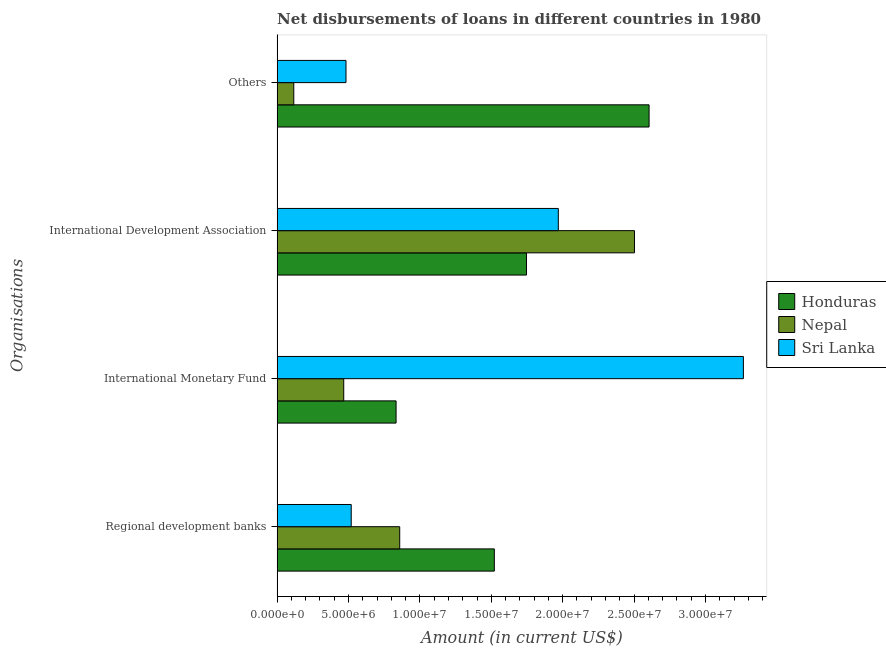What is the label of the 1st group of bars from the top?
Your response must be concise. Others. What is the amount of loan disimbursed by other organisations in Sri Lanka?
Make the answer very short. 4.82e+06. Across all countries, what is the maximum amount of loan disimbursed by international development association?
Offer a very short reply. 2.50e+07. Across all countries, what is the minimum amount of loan disimbursed by international development association?
Provide a succinct answer. 1.75e+07. In which country was the amount of loan disimbursed by international monetary fund maximum?
Give a very brief answer. Sri Lanka. In which country was the amount of loan disimbursed by international monetary fund minimum?
Your answer should be very brief. Nepal. What is the total amount of loan disimbursed by international development association in the graph?
Ensure brevity in your answer.  6.22e+07. What is the difference between the amount of loan disimbursed by international development association in Sri Lanka and that in Nepal?
Offer a very short reply. -5.33e+06. What is the difference between the amount of loan disimbursed by regional development banks in Honduras and the amount of loan disimbursed by international development association in Sri Lanka?
Your answer should be compact. -4.48e+06. What is the average amount of loan disimbursed by international development association per country?
Your answer should be very brief. 2.07e+07. What is the difference between the amount of loan disimbursed by international monetary fund and amount of loan disimbursed by regional development banks in Nepal?
Keep it short and to the point. -3.92e+06. In how many countries, is the amount of loan disimbursed by regional development banks greater than 14000000 US$?
Your answer should be very brief. 1. What is the ratio of the amount of loan disimbursed by other organisations in Honduras to that in Sri Lanka?
Your answer should be very brief. 5.4. Is the amount of loan disimbursed by regional development banks in Honduras less than that in Sri Lanka?
Keep it short and to the point. No. What is the difference between the highest and the second highest amount of loan disimbursed by international monetary fund?
Provide a succinct answer. 2.43e+07. What is the difference between the highest and the lowest amount of loan disimbursed by international monetary fund?
Offer a terse response. 2.80e+07. Is it the case that in every country, the sum of the amount of loan disimbursed by other organisations and amount of loan disimbursed by international development association is greater than the sum of amount of loan disimbursed by international monetary fund and amount of loan disimbursed by regional development banks?
Your answer should be compact. Yes. What does the 3rd bar from the top in International Development Association represents?
Your answer should be compact. Honduras. What does the 3rd bar from the bottom in International Monetary Fund represents?
Your answer should be compact. Sri Lanka. Are all the bars in the graph horizontal?
Keep it short and to the point. Yes. How many countries are there in the graph?
Make the answer very short. 3. What is the difference between two consecutive major ticks on the X-axis?
Provide a short and direct response. 5.00e+06. Are the values on the major ticks of X-axis written in scientific E-notation?
Ensure brevity in your answer.  Yes. Does the graph contain any zero values?
Provide a succinct answer. No. Does the graph contain grids?
Provide a short and direct response. No. Where does the legend appear in the graph?
Make the answer very short. Center right. What is the title of the graph?
Keep it short and to the point. Net disbursements of loans in different countries in 1980. What is the label or title of the X-axis?
Offer a very short reply. Amount (in current US$). What is the label or title of the Y-axis?
Your response must be concise. Organisations. What is the Amount (in current US$) in Honduras in Regional development banks?
Provide a succinct answer. 1.52e+07. What is the Amount (in current US$) in Nepal in Regional development banks?
Your response must be concise. 8.58e+06. What is the Amount (in current US$) in Sri Lanka in Regional development banks?
Ensure brevity in your answer.  5.19e+06. What is the Amount (in current US$) in Honduras in International Monetary Fund?
Offer a terse response. 8.33e+06. What is the Amount (in current US$) of Nepal in International Monetary Fund?
Your response must be concise. 4.66e+06. What is the Amount (in current US$) of Sri Lanka in International Monetary Fund?
Your response must be concise. 3.27e+07. What is the Amount (in current US$) of Honduras in International Development Association?
Your answer should be compact. 1.75e+07. What is the Amount (in current US$) of Nepal in International Development Association?
Provide a short and direct response. 2.50e+07. What is the Amount (in current US$) of Sri Lanka in International Development Association?
Provide a short and direct response. 1.97e+07. What is the Amount (in current US$) of Honduras in Others?
Your answer should be compact. 2.60e+07. What is the Amount (in current US$) in Nepal in Others?
Your answer should be compact. 1.17e+06. What is the Amount (in current US$) of Sri Lanka in Others?
Your answer should be very brief. 4.82e+06. Across all Organisations, what is the maximum Amount (in current US$) of Honduras?
Ensure brevity in your answer.  2.60e+07. Across all Organisations, what is the maximum Amount (in current US$) of Nepal?
Offer a very short reply. 2.50e+07. Across all Organisations, what is the maximum Amount (in current US$) in Sri Lanka?
Your answer should be compact. 3.27e+07. Across all Organisations, what is the minimum Amount (in current US$) in Honduras?
Make the answer very short. 8.33e+06. Across all Organisations, what is the minimum Amount (in current US$) of Nepal?
Provide a short and direct response. 1.17e+06. Across all Organisations, what is the minimum Amount (in current US$) in Sri Lanka?
Offer a very short reply. 4.82e+06. What is the total Amount (in current US$) in Honduras in the graph?
Ensure brevity in your answer.  6.71e+07. What is the total Amount (in current US$) in Nepal in the graph?
Ensure brevity in your answer.  3.94e+07. What is the total Amount (in current US$) of Sri Lanka in the graph?
Your answer should be compact. 6.24e+07. What is the difference between the Amount (in current US$) of Honduras in Regional development banks and that in International Monetary Fund?
Offer a terse response. 6.88e+06. What is the difference between the Amount (in current US$) of Nepal in Regional development banks and that in International Monetary Fund?
Keep it short and to the point. 3.92e+06. What is the difference between the Amount (in current US$) of Sri Lanka in Regional development banks and that in International Monetary Fund?
Offer a very short reply. -2.75e+07. What is the difference between the Amount (in current US$) of Honduras in Regional development banks and that in International Development Association?
Offer a terse response. -2.25e+06. What is the difference between the Amount (in current US$) of Nepal in Regional development banks and that in International Development Association?
Ensure brevity in your answer.  -1.64e+07. What is the difference between the Amount (in current US$) of Sri Lanka in Regional development banks and that in International Development Association?
Offer a very short reply. -1.45e+07. What is the difference between the Amount (in current US$) in Honduras in Regional development banks and that in Others?
Offer a very short reply. -1.08e+07. What is the difference between the Amount (in current US$) of Nepal in Regional development banks and that in Others?
Provide a succinct answer. 7.42e+06. What is the difference between the Amount (in current US$) in Sri Lanka in Regional development banks and that in Others?
Keep it short and to the point. 3.66e+05. What is the difference between the Amount (in current US$) of Honduras in International Monetary Fund and that in International Development Association?
Provide a succinct answer. -9.13e+06. What is the difference between the Amount (in current US$) in Nepal in International Monetary Fund and that in International Development Association?
Your answer should be compact. -2.04e+07. What is the difference between the Amount (in current US$) in Sri Lanka in International Monetary Fund and that in International Development Association?
Give a very brief answer. 1.30e+07. What is the difference between the Amount (in current US$) of Honduras in International Monetary Fund and that in Others?
Offer a very short reply. -1.77e+07. What is the difference between the Amount (in current US$) of Nepal in International Monetary Fund and that in Others?
Your response must be concise. 3.50e+06. What is the difference between the Amount (in current US$) in Sri Lanka in International Monetary Fund and that in Others?
Your response must be concise. 2.78e+07. What is the difference between the Amount (in current US$) in Honduras in International Development Association and that in Others?
Give a very brief answer. -8.59e+06. What is the difference between the Amount (in current US$) in Nepal in International Development Association and that in Others?
Ensure brevity in your answer.  2.39e+07. What is the difference between the Amount (in current US$) in Sri Lanka in International Development Association and that in Others?
Ensure brevity in your answer.  1.49e+07. What is the difference between the Amount (in current US$) of Honduras in Regional development banks and the Amount (in current US$) of Nepal in International Monetary Fund?
Provide a succinct answer. 1.05e+07. What is the difference between the Amount (in current US$) of Honduras in Regional development banks and the Amount (in current US$) of Sri Lanka in International Monetary Fund?
Your answer should be compact. -1.74e+07. What is the difference between the Amount (in current US$) in Nepal in Regional development banks and the Amount (in current US$) in Sri Lanka in International Monetary Fund?
Make the answer very short. -2.41e+07. What is the difference between the Amount (in current US$) of Honduras in Regional development banks and the Amount (in current US$) of Nepal in International Development Association?
Ensure brevity in your answer.  -9.81e+06. What is the difference between the Amount (in current US$) of Honduras in Regional development banks and the Amount (in current US$) of Sri Lanka in International Development Association?
Offer a terse response. -4.48e+06. What is the difference between the Amount (in current US$) in Nepal in Regional development banks and the Amount (in current US$) in Sri Lanka in International Development Association?
Keep it short and to the point. -1.11e+07. What is the difference between the Amount (in current US$) in Honduras in Regional development banks and the Amount (in current US$) in Nepal in Others?
Provide a succinct answer. 1.40e+07. What is the difference between the Amount (in current US$) of Honduras in Regional development banks and the Amount (in current US$) of Sri Lanka in Others?
Provide a succinct answer. 1.04e+07. What is the difference between the Amount (in current US$) in Nepal in Regional development banks and the Amount (in current US$) in Sri Lanka in Others?
Offer a very short reply. 3.76e+06. What is the difference between the Amount (in current US$) of Honduras in International Monetary Fund and the Amount (in current US$) of Nepal in International Development Association?
Keep it short and to the point. -1.67e+07. What is the difference between the Amount (in current US$) of Honduras in International Monetary Fund and the Amount (in current US$) of Sri Lanka in International Development Association?
Your answer should be very brief. -1.14e+07. What is the difference between the Amount (in current US$) of Nepal in International Monetary Fund and the Amount (in current US$) of Sri Lanka in International Development Association?
Your answer should be very brief. -1.50e+07. What is the difference between the Amount (in current US$) in Honduras in International Monetary Fund and the Amount (in current US$) in Nepal in Others?
Offer a terse response. 7.16e+06. What is the difference between the Amount (in current US$) of Honduras in International Monetary Fund and the Amount (in current US$) of Sri Lanka in Others?
Your answer should be compact. 3.51e+06. What is the difference between the Amount (in current US$) of Nepal in International Monetary Fund and the Amount (in current US$) of Sri Lanka in Others?
Provide a short and direct response. -1.58e+05. What is the difference between the Amount (in current US$) of Honduras in International Development Association and the Amount (in current US$) of Nepal in Others?
Offer a very short reply. 1.63e+07. What is the difference between the Amount (in current US$) of Honduras in International Development Association and the Amount (in current US$) of Sri Lanka in Others?
Provide a short and direct response. 1.26e+07. What is the difference between the Amount (in current US$) of Nepal in International Development Association and the Amount (in current US$) of Sri Lanka in Others?
Make the answer very short. 2.02e+07. What is the average Amount (in current US$) of Honduras per Organisations?
Offer a very short reply. 1.68e+07. What is the average Amount (in current US$) of Nepal per Organisations?
Your response must be concise. 9.86e+06. What is the average Amount (in current US$) in Sri Lanka per Organisations?
Keep it short and to the point. 1.56e+07. What is the difference between the Amount (in current US$) of Honduras and Amount (in current US$) of Nepal in Regional development banks?
Your answer should be compact. 6.63e+06. What is the difference between the Amount (in current US$) of Honduras and Amount (in current US$) of Sri Lanka in Regional development banks?
Offer a terse response. 1.00e+07. What is the difference between the Amount (in current US$) in Nepal and Amount (in current US$) in Sri Lanka in Regional development banks?
Ensure brevity in your answer.  3.40e+06. What is the difference between the Amount (in current US$) in Honduras and Amount (in current US$) in Nepal in International Monetary Fund?
Keep it short and to the point. 3.66e+06. What is the difference between the Amount (in current US$) of Honduras and Amount (in current US$) of Sri Lanka in International Monetary Fund?
Your answer should be compact. -2.43e+07. What is the difference between the Amount (in current US$) of Nepal and Amount (in current US$) of Sri Lanka in International Monetary Fund?
Provide a short and direct response. -2.80e+07. What is the difference between the Amount (in current US$) in Honduras and Amount (in current US$) in Nepal in International Development Association?
Your answer should be very brief. -7.56e+06. What is the difference between the Amount (in current US$) in Honduras and Amount (in current US$) in Sri Lanka in International Development Association?
Provide a short and direct response. -2.23e+06. What is the difference between the Amount (in current US$) of Nepal and Amount (in current US$) of Sri Lanka in International Development Association?
Your answer should be compact. 5.33e+06. What is the difference between the Amount (in current US$) of Honduras and Amount (in current US$) of Nepal in Others?
Offer a terse response. 2.49e+07. What is the difference between the Amount (in current US$) in Honduras and Amount (in current US$) in Sri Lanka in Others?
Your response must be concise. 2.12e+07. What is the difference between the Amount (in current US$) in Nepal and Amount (in current US$) in Sri Lanka in Others?
Your answer should be compact. -3.66e+06. What is the ratio of the Amount (in current US$) in Honduras in Regional development banks to that in International Monetary Fund?
Keep it short and to the point. 1.83. What is the ratio of the Amount (in current US$) of Nepal in Regional development banks to that in International Monetary Fund?
Provide a succinct answer. 1.84. What is the ratio of the Amount (in current US$) in Sri Lanka in Regional development banks to that in International Monetary Fund?
Provide a short and direct response. 0.16. What is the ratio of the Amount (in current US$) in Honduras in Regional development banks to that in International Development Association?
Offer a terse response. 0.87. What is the ratio of the Amount (in current US$) in Nepal in Regional development banks to that in International Development Association?
Keep it short and to the point. 0.34. What is the ratio of the Amount (in current US$) of Sri Lanka in Regional development banks to that in International Development Association?
Provide a short and direct response. 0.26. What is the ratio of the Amount (in current US$) of Honduras in Regional development banks to that in Others?
Keep it short and to the point. 0.58. What is the ratio of the Amount (in current US$) of Nepal in Regional development banks to that in Others?
Provide a short and direct response. 7.36. What is the ratio of the Amount (in current US$) in Sri Lanka in Regional development banks to that in Others?
Keep it short and to the point. 1.08. What is the ratio of the Amount (in current US$) in Honduras in International Monetary Fund to that in International Development Association?
Your response must be concise. 0.48. What is the ratio of the Amount (in current US$) of Nepal in International Monetary Fund to that in International Development Association?
Keep it short and to the point. 0.19. What is the ratio of the Amount (in current US$) in Sri Lanka in International Monetary Fund to that in International Development Association?
Ensure brevity in your answer.  1.66. What is the ratio of the Amount (in current US$) of Honduras in International Monetary Fund to that in Others?
Provide a succinct answer. 0.32. What is the ratio of the Amount (in current US$) of Nepal in International Monetary Fund to that in Others?
Your response must be concise. 4. What is the ratio of the Amount (in current US$) of Sri Lanka in International Monetary Fund to that in Others?
Provide a short and direct response. 6.77. What is the ratio of the Amount (in current US$) in Honduras in International Development Association to that in Others?
Your response must be concise. 0.67. What is the ratio of the Amount (in current US$) of Nepal in International Development Association to that in Others?
Give a very brief answer. 21.46. What is the ratio of the Amount (in current US$) of Sri Lanka in International Development Association to that in Others?
Make the answer very short. 4.08. What is the difference between the highest and the second highest Amount (in current US$) in Honduras?
Keep it short and to the point. 8.59e+06. What is the difference between the highest and the second highest Amount (in current US$) in Nepal?
Offer a terse response. 1.64e+07. What is the difference between the highest and the second highest Amount (in current US$) in Sri Lanka?
Your response must be concise. 1.30e+07. What is the difference between the highest and the lowest Amount (in current US$) in Honduras?
Ensure brevity in your answer.  1.77e+07. What is the difference between the highest and the lowest Amount (in current US$) in Nepal?
Your answer should be very brief. 2.39e+07. What is the difference between the highest and the lowest Amount (in current US$) in Sri Lanka?
Give a very brief answer. 2.78e+07. 